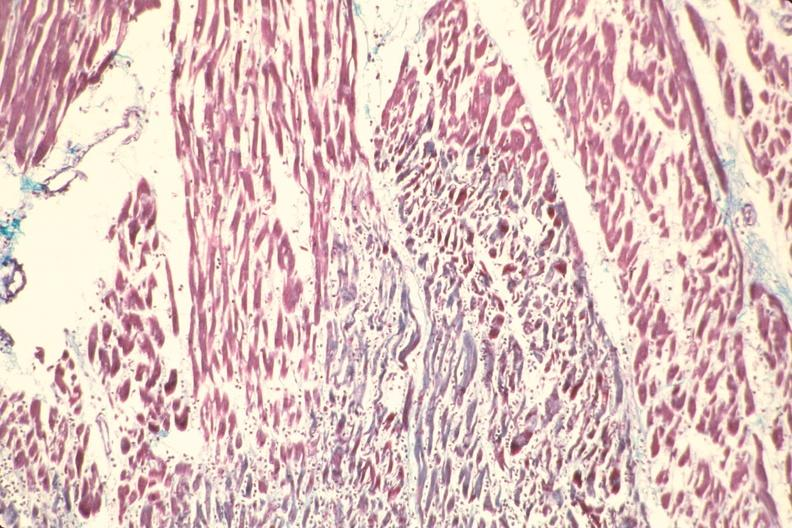s cardiovascular present?
Answer the question using a single word or phrase. Yes 